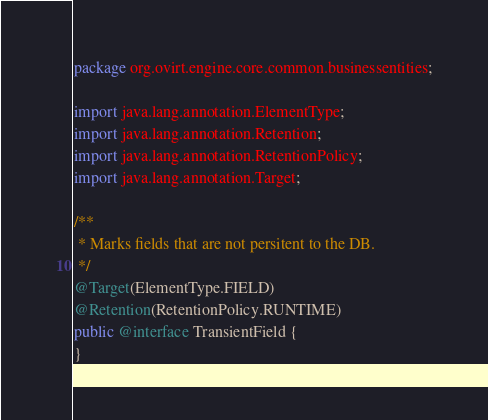Convert code to text. <code><loc_0><loc_0><loc_500><loc_500><_Java_>package org.ovirt.engine.core.common.businessentities;

import java.lang.annotation.ElementType;
import java.lang.annotation.Retention;
import java.lang.annotation.RetentionPolicy;
import java.lang.annotation.Target;

/**
 * Marks fields that are not persitent to the DB.
 */
@Target(ElementType.FIELD)
@Retention(RetentionPolicy.RUNTIME)
public @interface TransientField {
}
</code> 